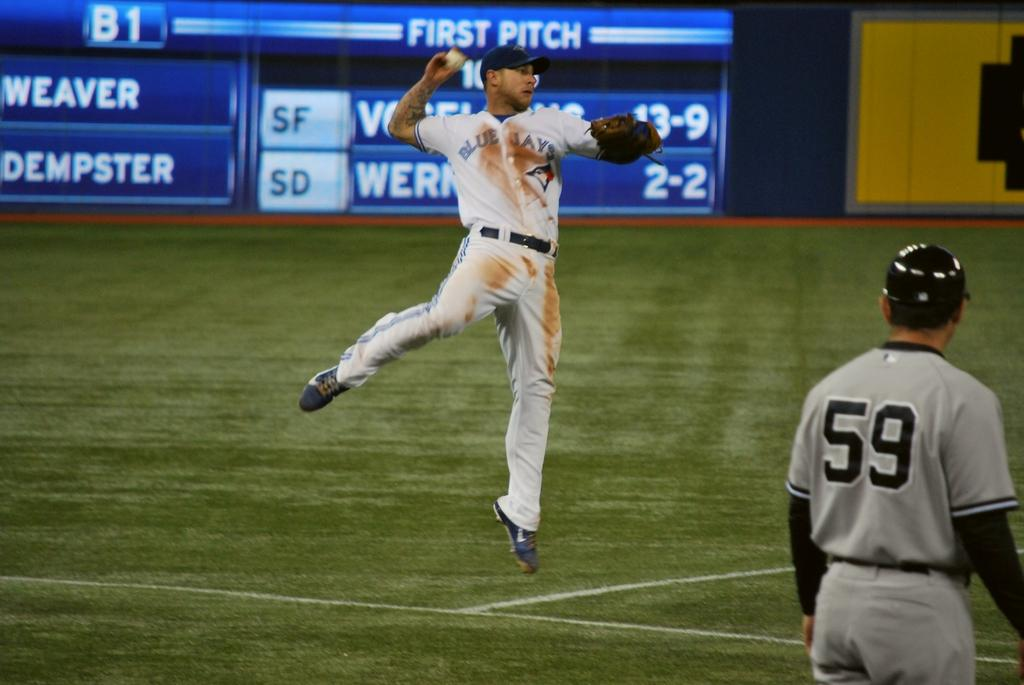Provide a one-sentence caption for the provided image. A baseball player on a field has a 59 on his jersey. 